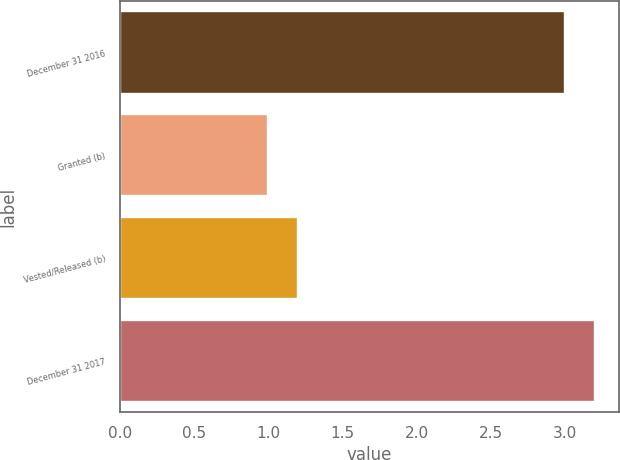Convert chart to OTSL. <chart><loc_0><loc_0><loc_500><loc_500><bar_chart><fcel>December 31 2016<fcel>Granted (b)<fcel>Vested/Released (b)<fcel>December 31 2017<nl><fcel>3<fcel>1<fcel>1.2<fcel>3.2<nl></chart> 